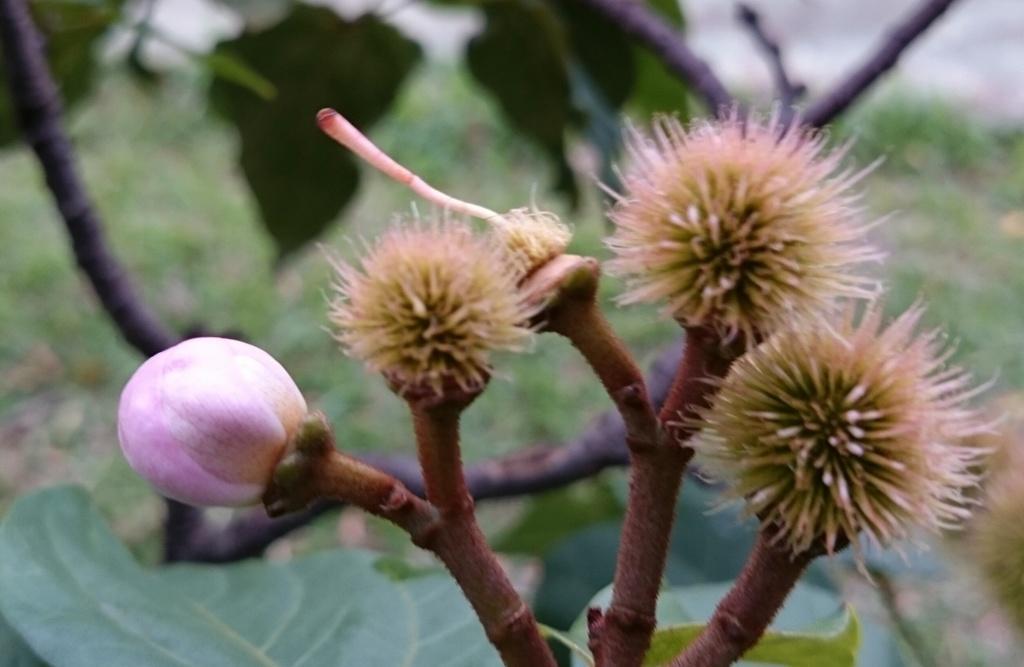Describe this image in one or two sentences. In this image there are flowers and plants, behind the plant there are leaves. 